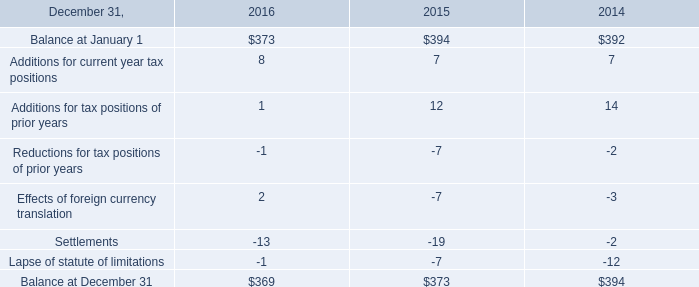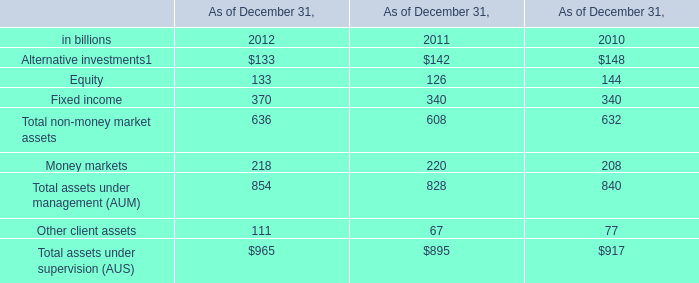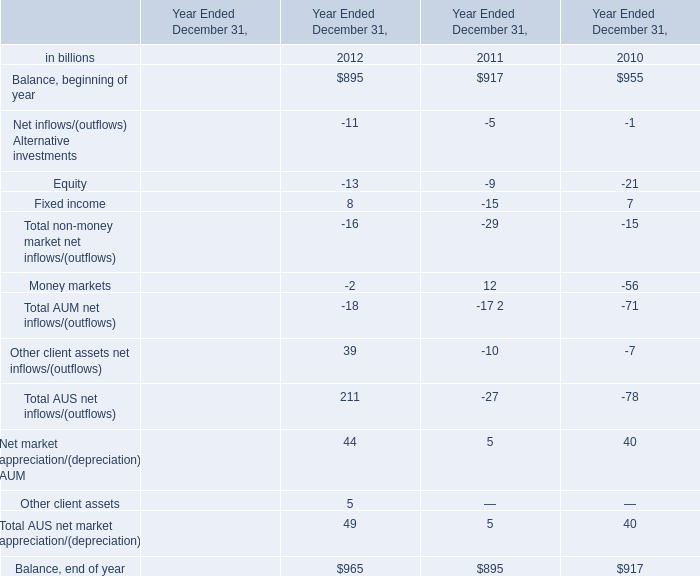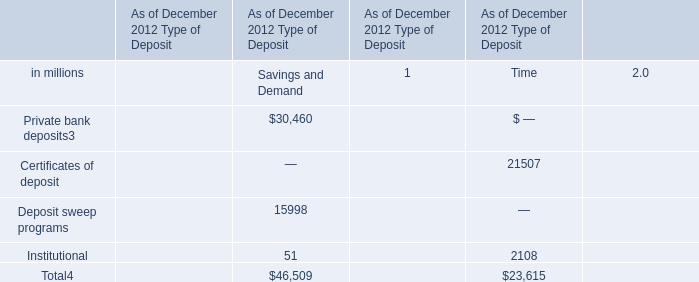What is the proportion of all non-money market net inflows/(outflows) that are greater than -10 to the total amount of non-money market net inflows/(outflows) , in 2011? (in %) 
Computations: ((-5 + -9) / -29)
Answer: 0.48276. 